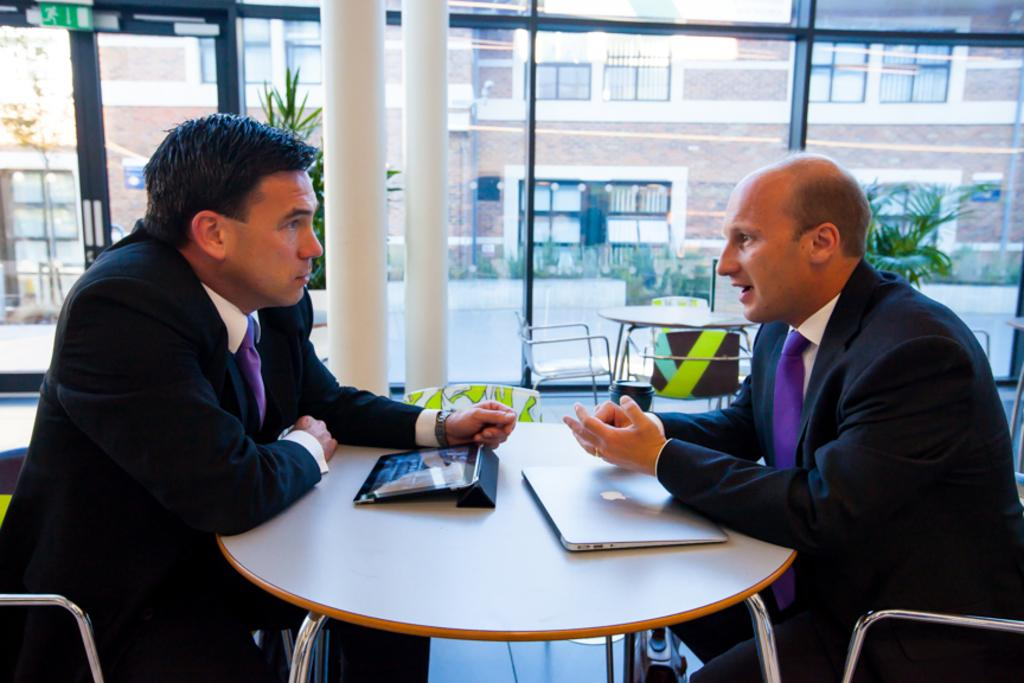How many people are sitting in the image? There are two persons sitting on chairs in the image. What electronic devices can be seen on the table? There is a tablet and a laptop on the table. What can be seen in the background of the image? There is a road, a red-colored building, and plants in the background of the image. What type of organization is being discussed by the two persons in the image? There is no indication in the image that the two persons are discussing any organization. 